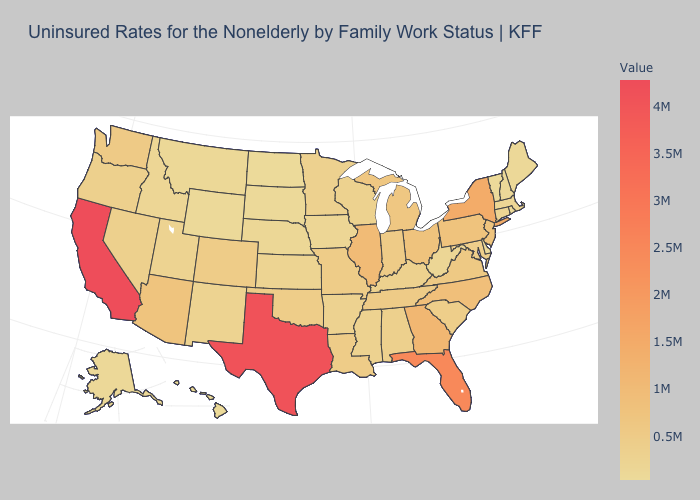Among the states that border New Jersey , does New York have the highest value?
Short answer required. Yes. Is the legend a continuous bar?
Quick response, please. Yes. Does Michigan have a lower value than Maine?
Short answer required. No. Is the legend a continuous bar?
Short answer required. Yes. Among the states that border Virginia , does Tennessee have the lowest value?
Answer briefly. No. Does Wyoming have a lower value than Louisiana?
Short answer required. Yes. Among the states that border Montana , which have the highest value?
Concise answer only. Idaho. Which states have the highest value in the USA?
Be succinct. California. Which states have the highest value in the USA?
Concise answer only. California. 